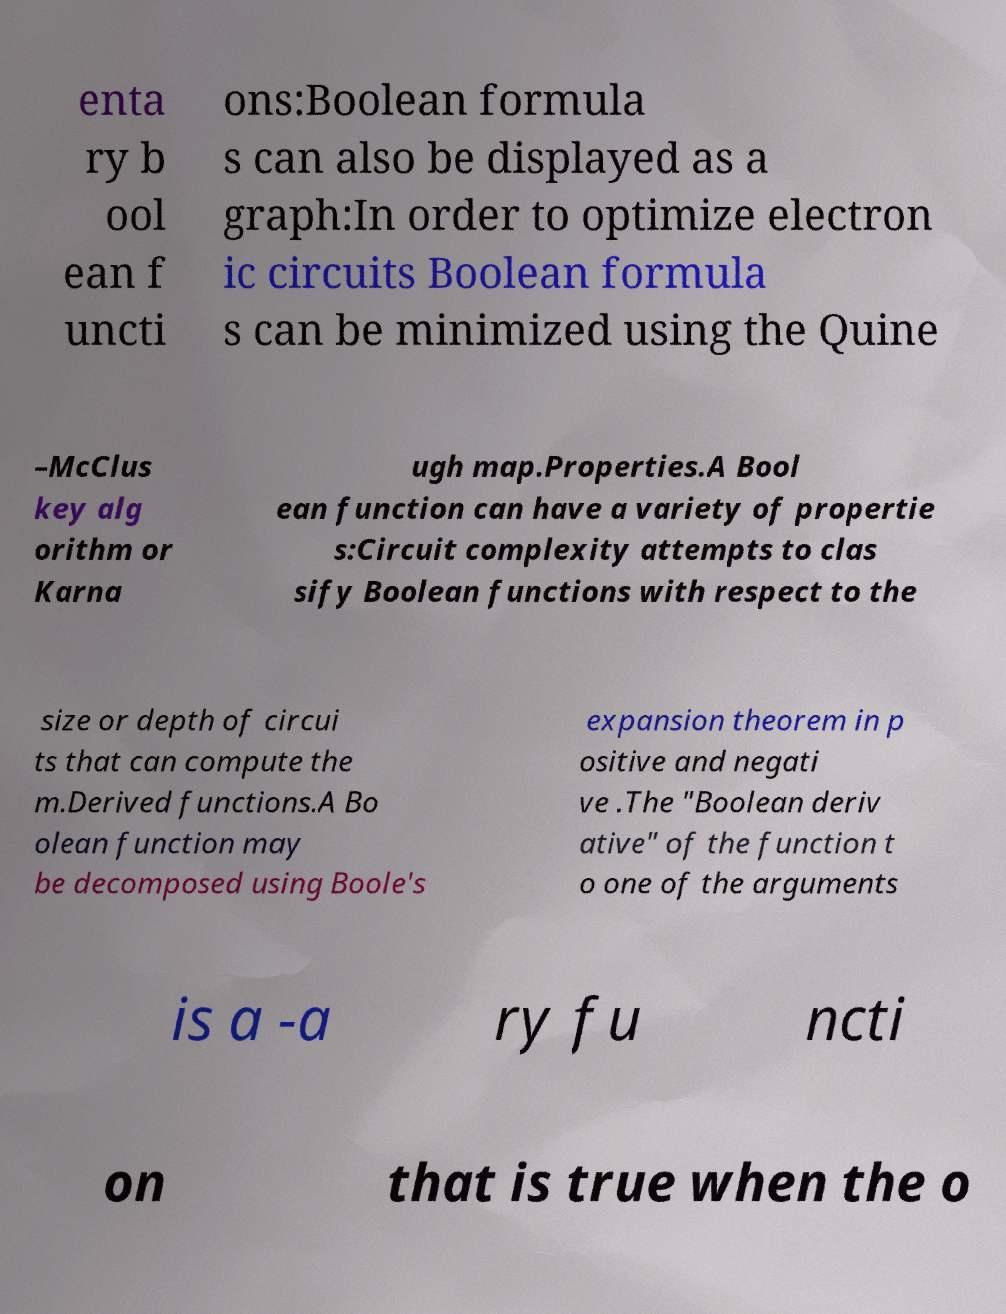What messages or text are displayed in this image? I need them in a readable, typed format. enta ry b ool ean f uncti ons:Boolean formula s can also be displayed as a graph:In order to optimize electron ic circuits Boolean formula s can be minimized using the Quine –McClus key alg orithm or Karna ugh map.Properties.A Bool ean function can have a variety of propertie s:Circuit complexity attempts to clas sify Boolean functions with respect to the size or depth of circui ts that can compute the m.Derived functions.A Bo olean function may be decomposed using Boole's expansion theorem in p ositive and negati ve .The "Boolean deriv ative" of the function t o one of the arguments is a -a ry fu ncti on that is true when the o 